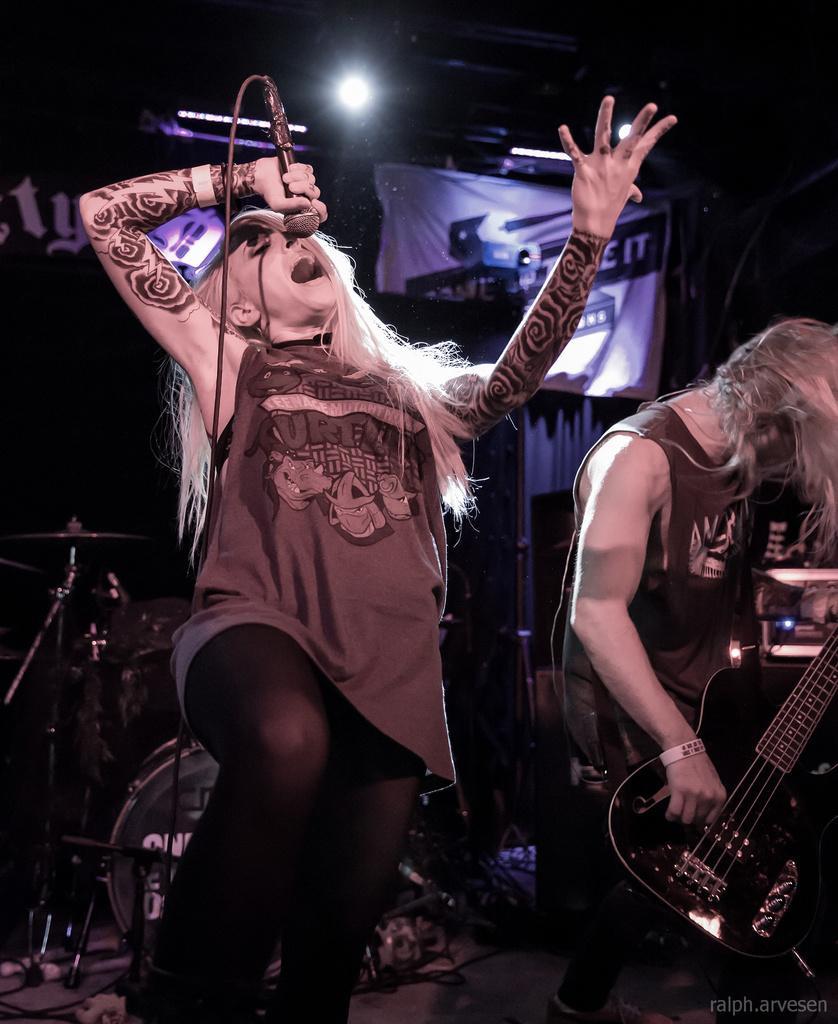Please provide a concise description of this image. As we can see in the image, there are two persons standing on stage. The person on the right side is holding guitar and the person on the left side is singing a song. 